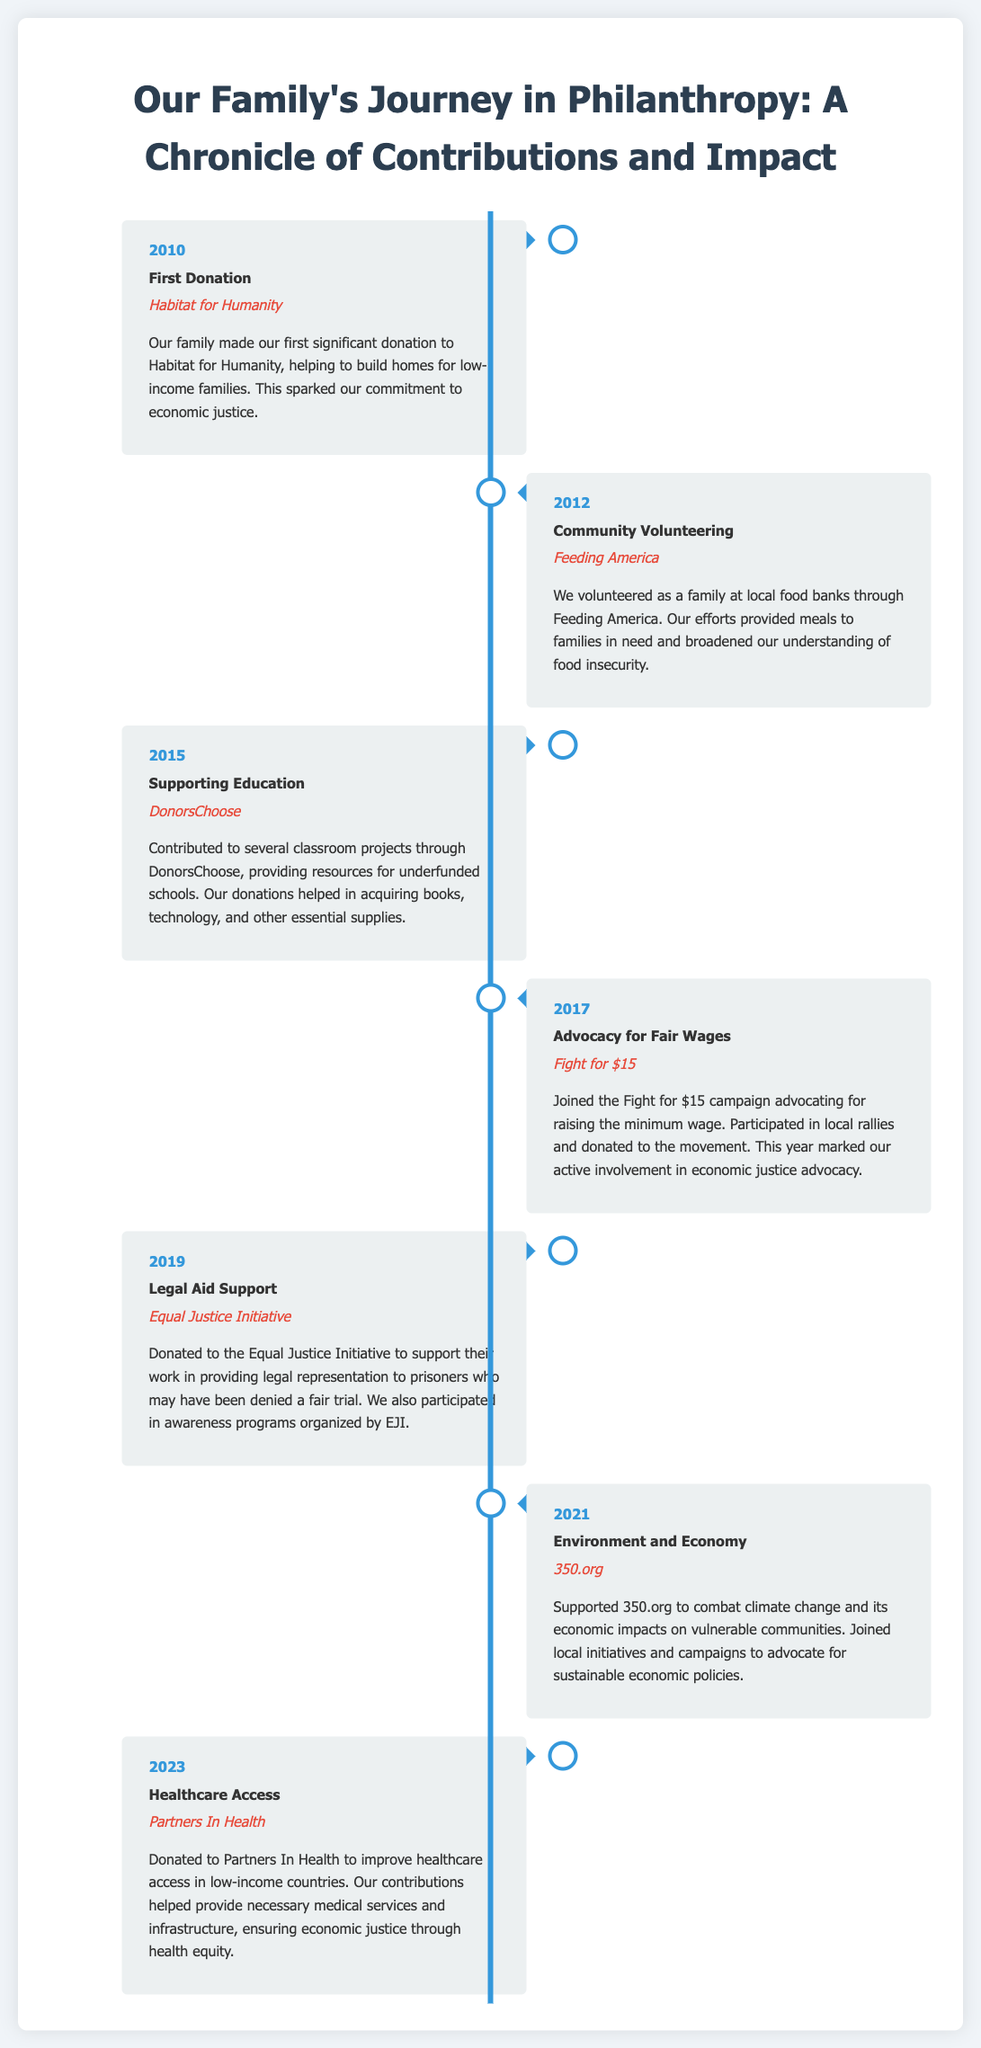What was the family's first significant donation? The document states that the family's first significant donation was to Habitat for Humanity, which helped build homes for low-income families.
Answer: Habitat for Humanity In which year did the family volunteer at local food banks? The timeline indicates that the family volunteered as a family at local food banks in the year 2012.
Answer: 2012 What organization did the family support for education-related projects? According to the document, the family contributed to classroom projects through DonorsChoose, which is mentioned specifically for educational support.
Answer: DonorsChoose What campaign did the family join in 2017? The document mentions that the family joined the Fight for $15 campaign in 2017, advocating for raising the minimum wage.
Answer: Fight for $15 Which organization did the family donate to for legal aid support? The timeline specifies that the family donated to the Equal Justice Initiative for providing legal representation in 2019.
Answer: Equal Justice Initiative What year did the family support environmental initiatives? From the timeline, it is mentioned that the family supported 350.org in the year 2021 to combat climate change.
Answer: 2021 What was the focus of the family's contribution in 2023? The document indicates that the family's focus in 2023 was on improving healthcare access, demonstrated through their donation to Partners In Health.
Answer: Healthcare access Which organization was involved with providing medical services in low-income countries? According to the document, Partners In Health was the organization involved in providing necessary medical services and infrastructure.
Answer: Partners In Health What type of contributions did the family primarily engage in? The overall contributions documented in the timeline reflect voluntary work and financial donations aimed at promoting economic justice.
Answer: Economic justice 